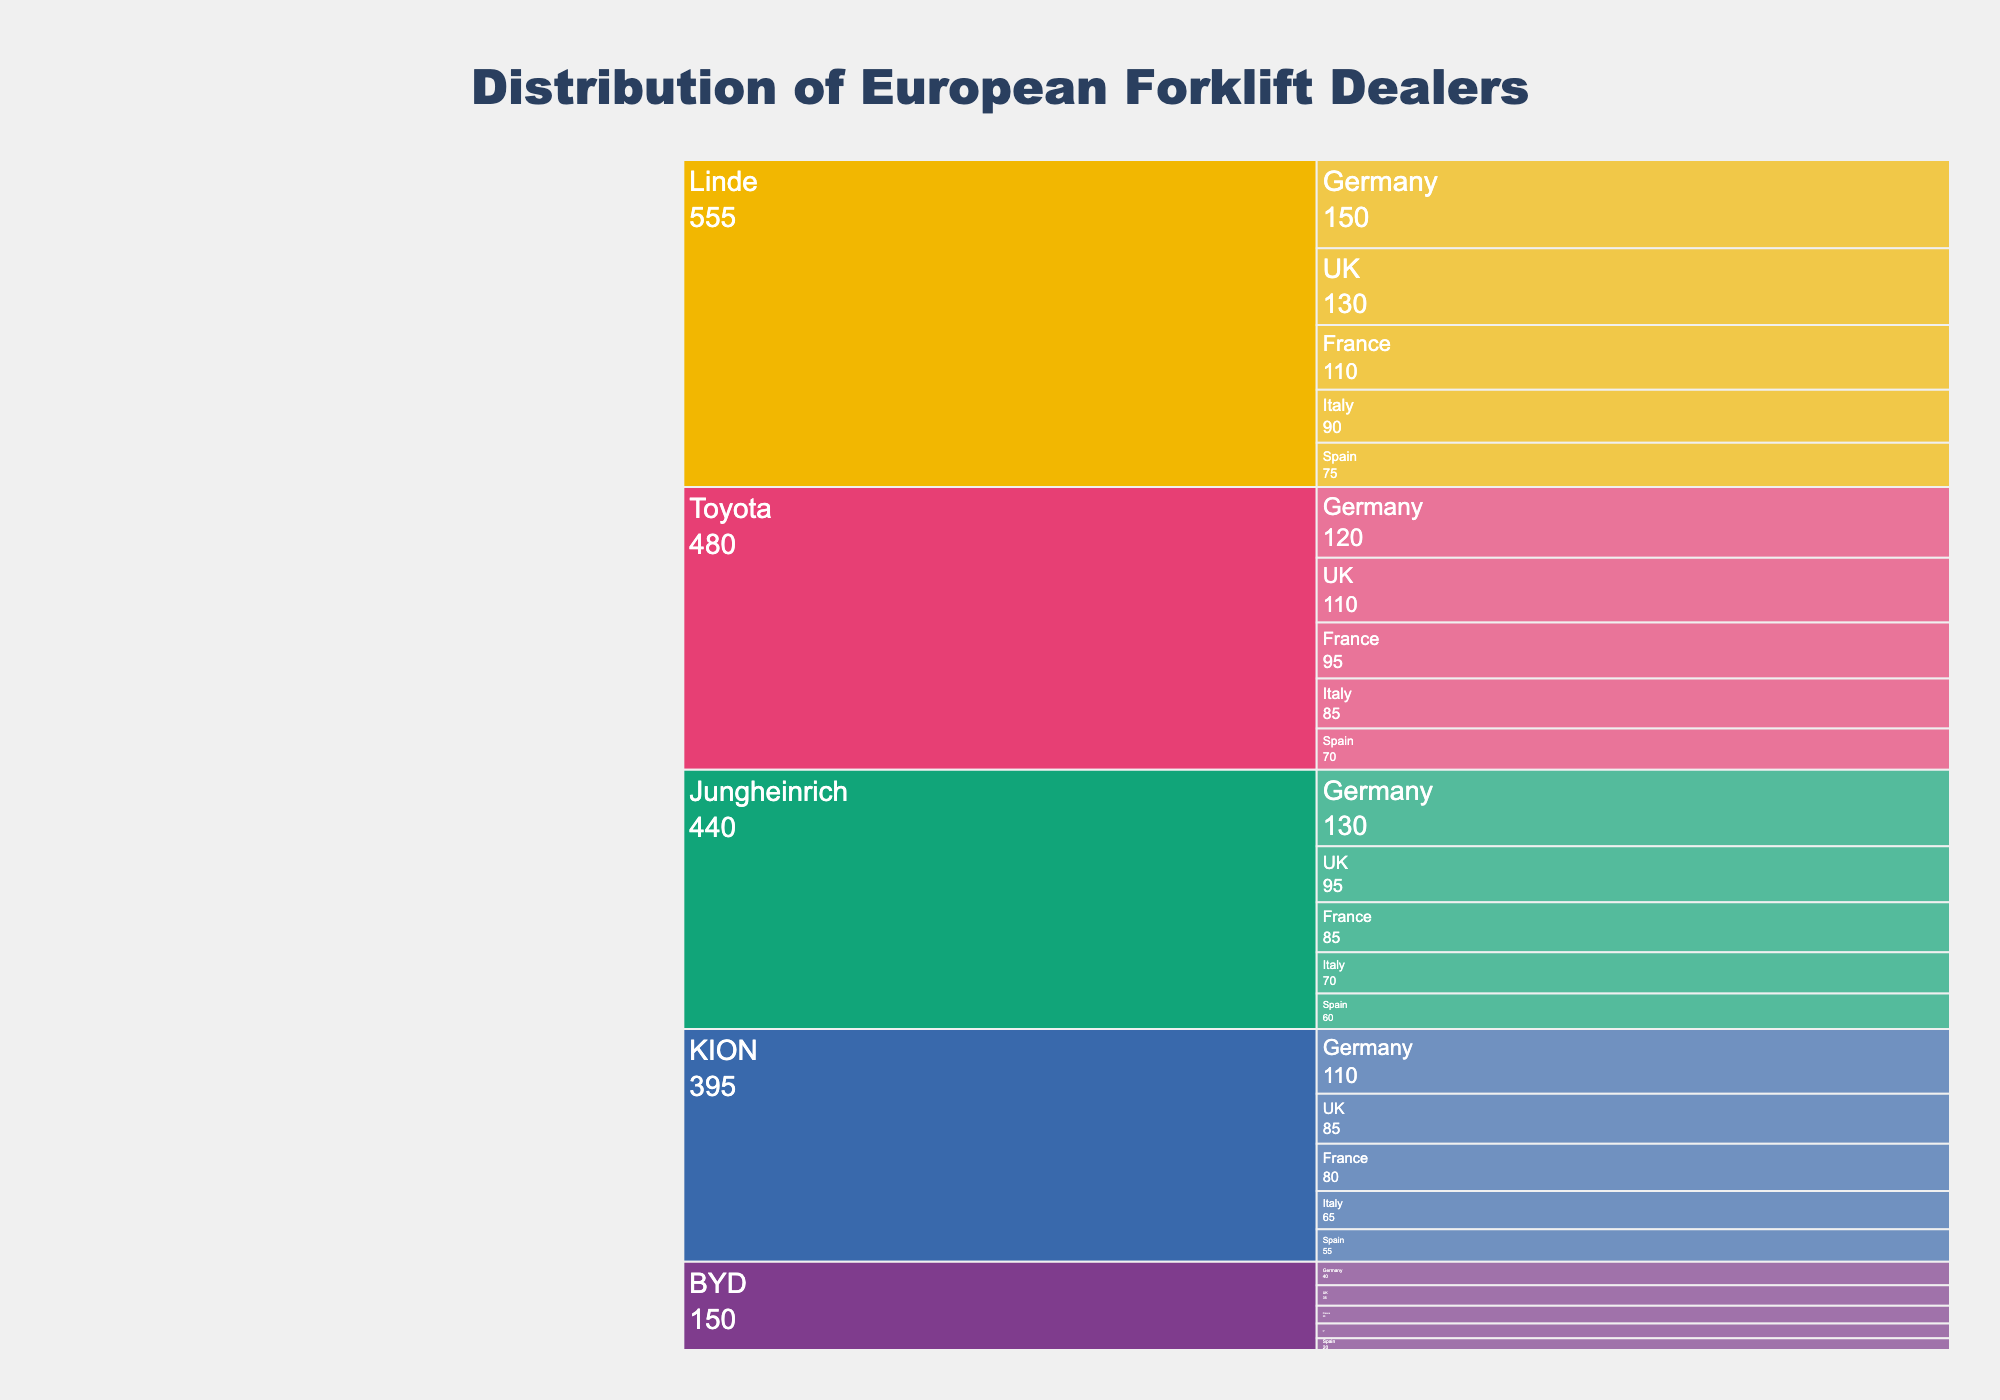How many dealers does Toyota have in Germany? Locate the section for Toyota in the chart, then find the subdivided section for Germany and read the number of dealers.
Answer: 120 Which country has the lowest number of BYD dealers? Find the sections corresponding to BYD, then look at each country's subdivision and compare the dealer counts to identify the lowest.
Answer: Spain What is the total number of dealers represented by Linde across all countries? Add the number of dealers for Linde in Germany (150), France (110), Italy (90), Spain (75), and the UK (130) to find the total.
Answer: 555 Which brand has the highest number of dealers in Spain? Check the sections for each brand and their respective subdivisions for Spain, then compare the numbers to identify the highest.
Answer: Linde How many more dealers does Jungheinrich have in Germany compared to BYD in Germany? Subtract the number of BYD dealers in Germany (40) from the number of Jungheinrich dealers in Germany (130).
Answer: 90 What is the mean number of dealers for KION across the listed countries? Sum the number of KION dealers in all countries and then divide by the number of countries: (110 + 80 + 65 + 55 + 85) / 5.
Answer: 79 Which two brands have an equal number of dealers in France, and what is that number? Check the sections for each brand's subdivision in France and compare the dealer counts to find the two brands with the same number.
Answer: BYD and Jungheinrich, 30 In which country does Toyota have the second highest number of dealers? Examine Toyota's dealer numbers for each country, then identify the second-largest value.
Answer: UK What is the ratio of Linde dealers to Toyota dealers in Italy? Divide the number of Linde dealers in Italy (90) by the number of Toyota dealers in Italy (85).
Answer: Approximately 1.06 Of the listed brands, which one has the highest total representation in the European market (sum across all countries)? Sum the dealer counts for each brand across all countries and compare to find the highest total.
Answer: Linde 